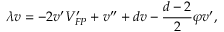<formula> <loc_0><loc_0><loc_500><loc_500>\lambda v = - 2 v ^ { \prime } V _ { F P } ^ { \prime } + v ^ { \prime \prime } + d v - \frac { d - 2 } { 2 } \varphi v ^ { \prime } ,</formula> 